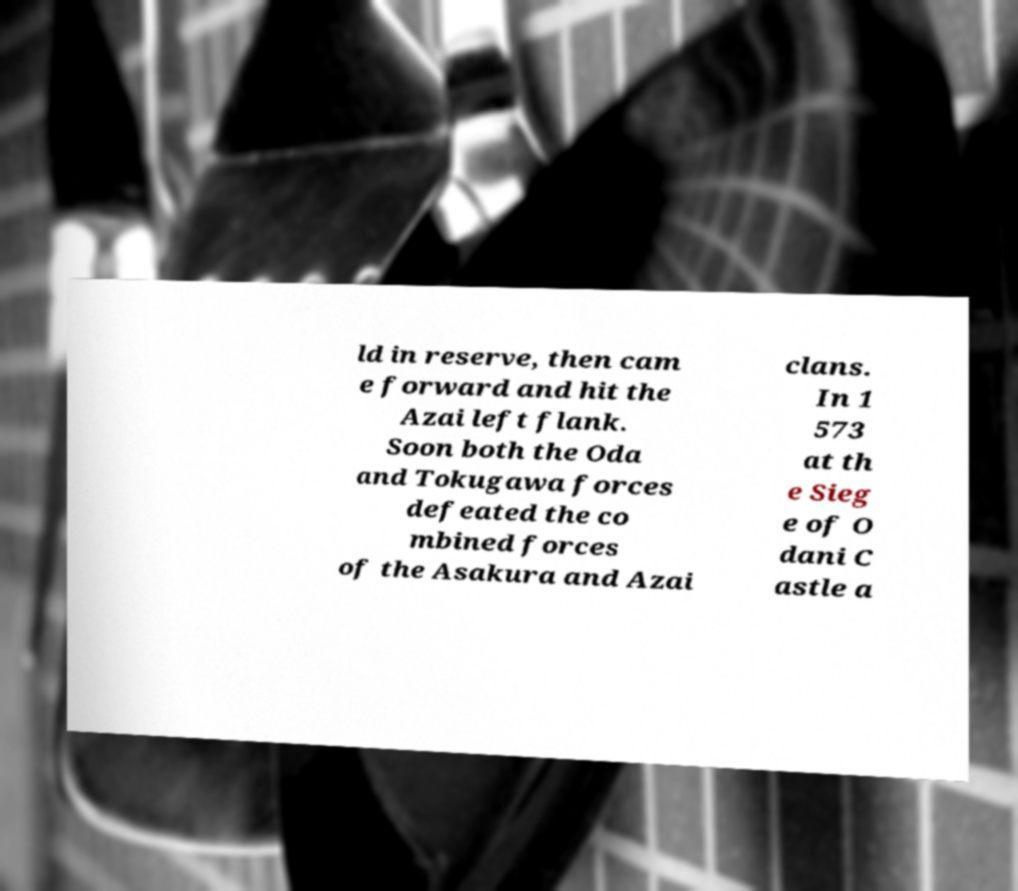Please read and relay the text visible in this image. What does it say? ld in reserve, then cam e forward and hit the Azai left flank. Soon both the Oda and Tokugawa forces defeated the co mbined forces of the Asakura and Azai clans. In 1 573 at th e Sieg e of O dani C astle a 